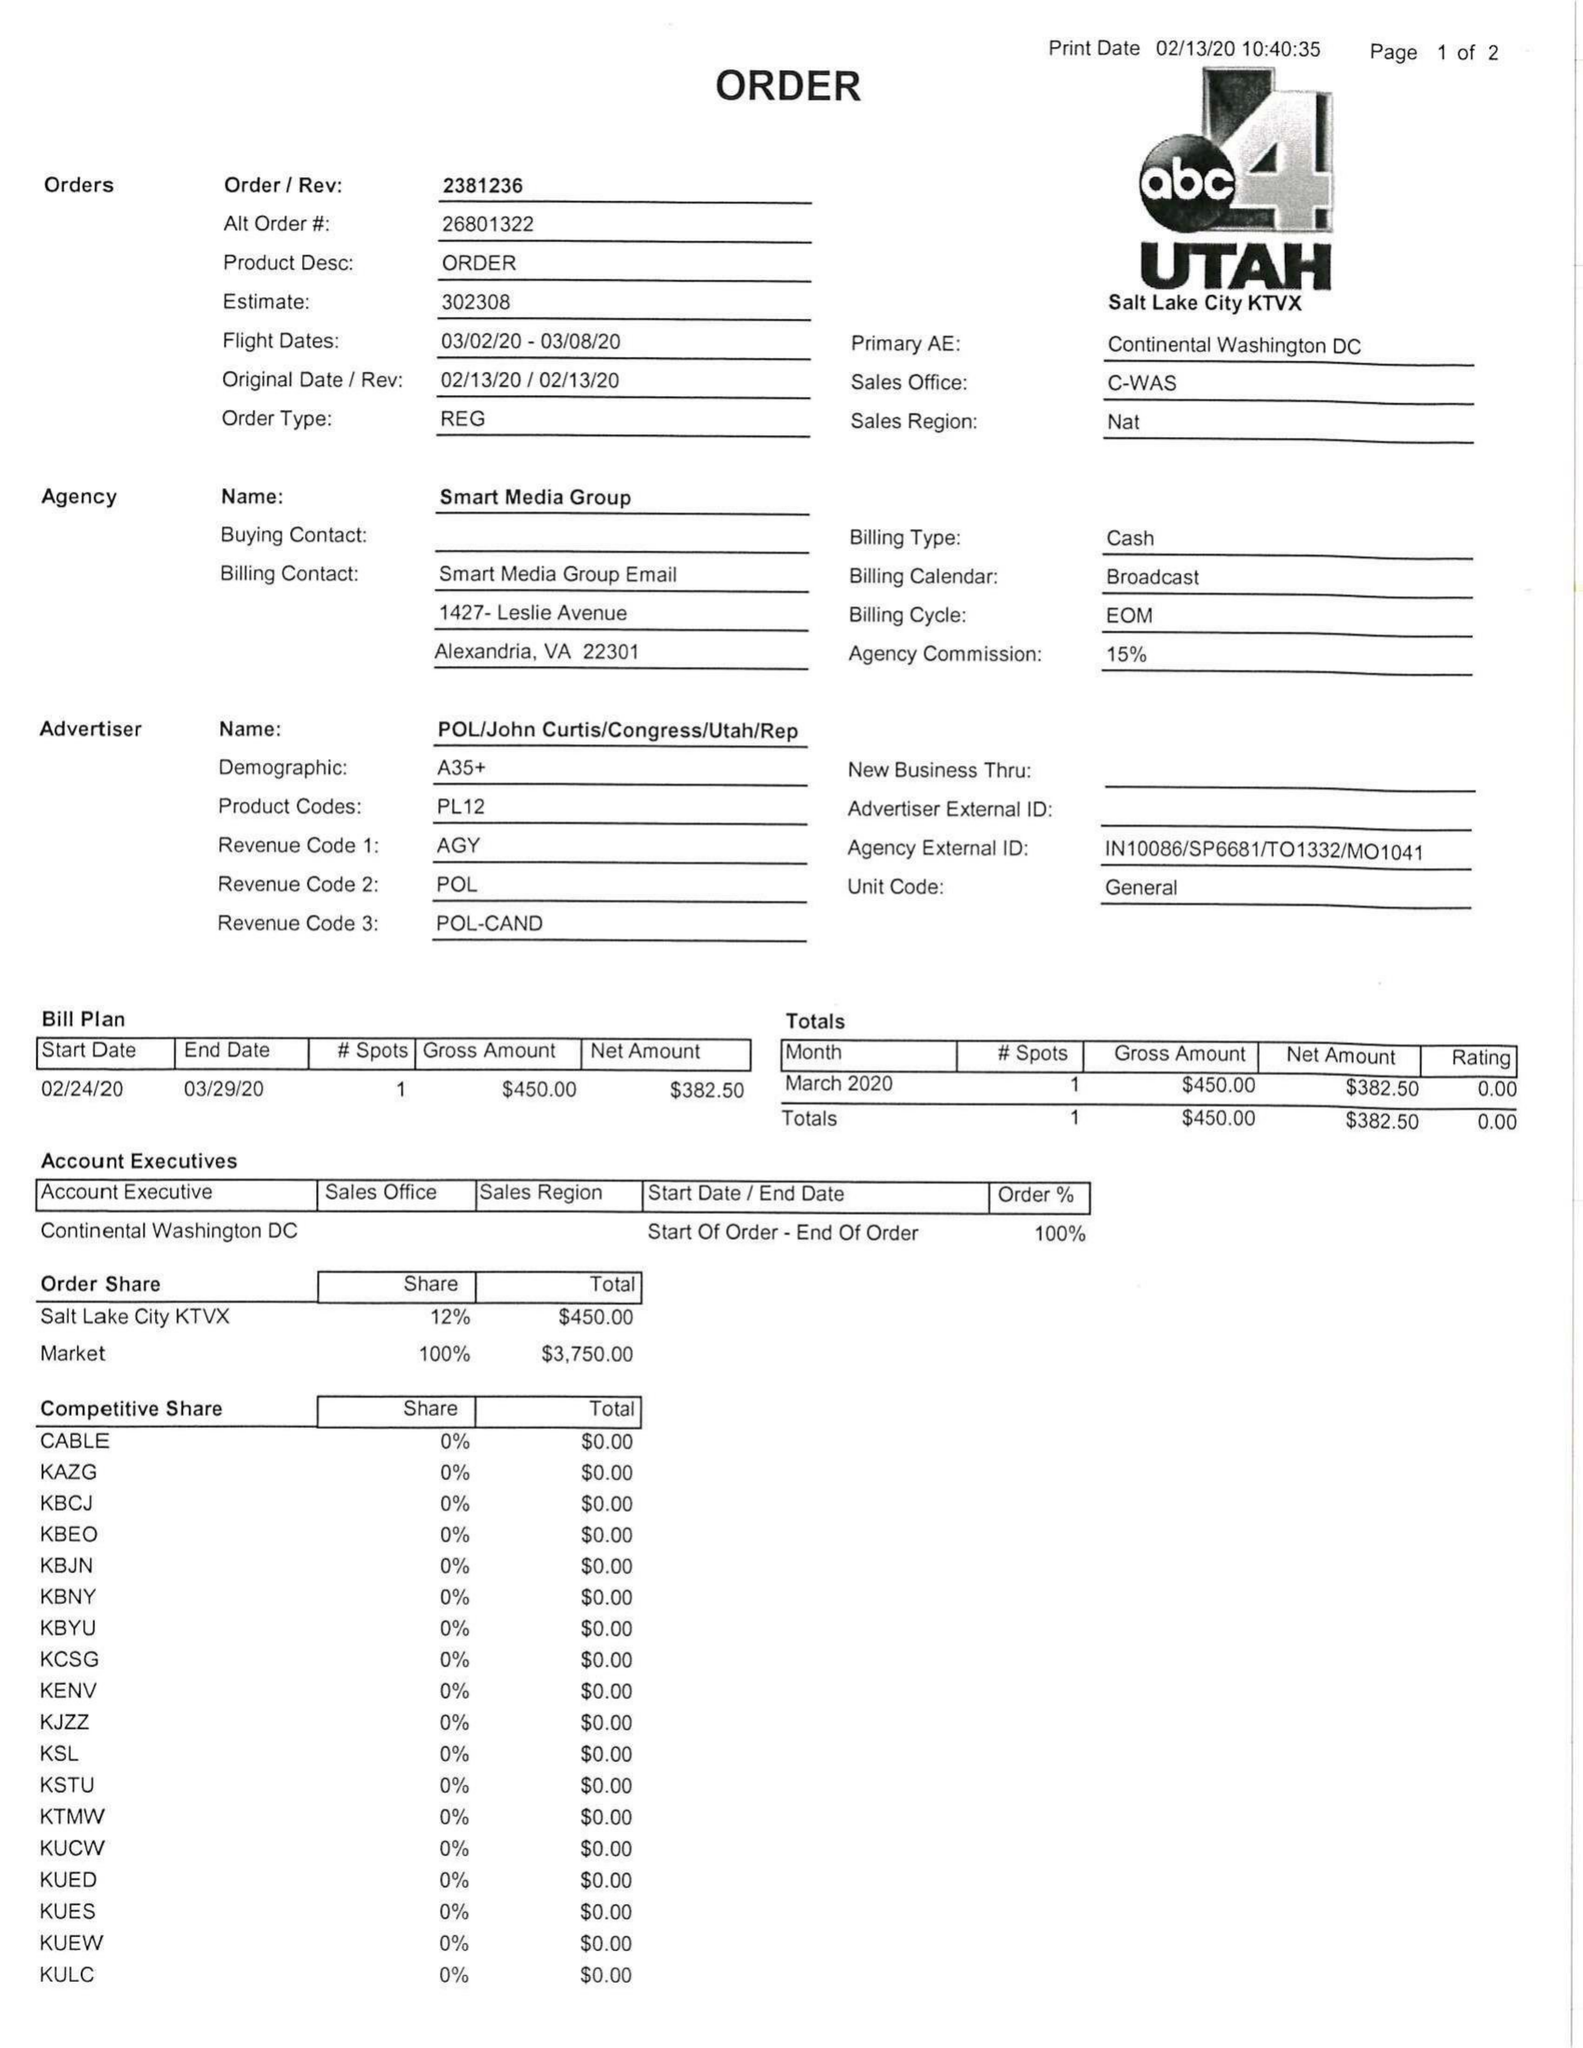What is the value for the gross_amount?
Answer the question using a single word or phrase. 450.00 